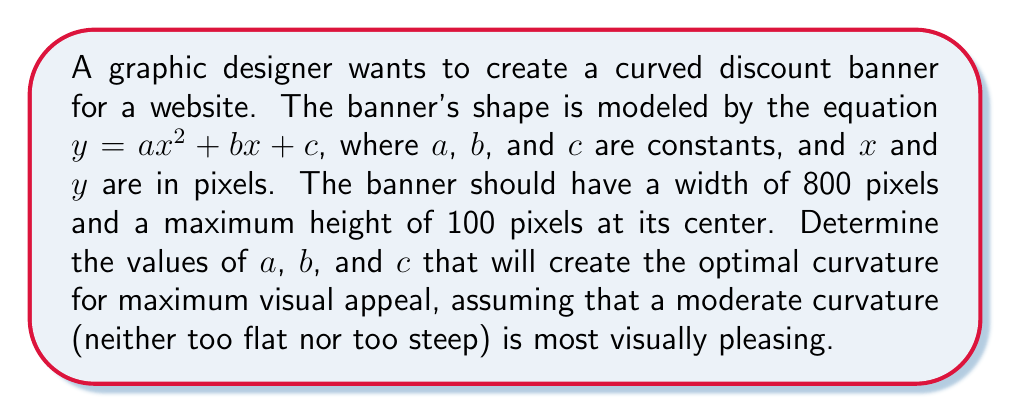Provide a solution to this math problem. 1) The banner's width is 800 pixels, so it extends from $x = -400$ to $x = 400$.

2) The maximum height of 100 pixels occurs at the center $(x = 0)$, so:
   $100 = a(0)^2 + b(0) + c$
   $100 = c$

3) For symmetry and visual appeal, the curve should be centered at $x = 0$, which means $b = 0$.

4) At the edges of the banner $(x = ±400)$, we want the height to be 0:
   $0 = a(400)^2 + 0 + 100$
   $0 = 160000a + 100$
   $-100 = 160000a$
   $a = -\frac{1}{1600} = -0.000625$

5) Therefore, the equation of the curve is:
   $y = -0.000625x^2 + 100$

6) To verify the maximum height:
   $\frac{dy}{dx} = -0.00125x$
   Set this to 0: $-0.00125x = 0$
   $x = 0$, confirming the maximum is at the center.

7) The curvature $\kappa$ at any point is given by:
   $$\kappa = \frac{|f''(x)|}{(1 + (f'(x))^2)^{3/2}}$$

   Where $f''(x) = -0.00125$ (constant) and $f'(x) = -0.00125x$

8) At the center $(x = 0)$, the curvature is:
   $$\kappa = \frac{0.00125}{(1 + 0^2)^{3/2}} = 0.00125$$

This curvature provides a moderate, visually pleasing curve for the discount banner.
Answer: $y = -0.000625x^2 + 100$ 